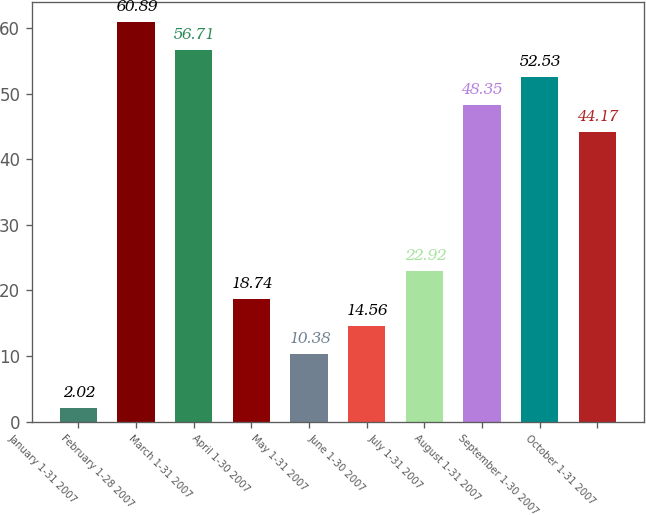Convert chart to OTSL. <chart><loc_0><loc_0><loc_500><loc_500><bar_chart><fcel>January 1-31 2007<fcel>February 1-28 2007<fcel>March 1-31 2007<fcel>April 1-30 2007<fcel>May 1-31 2007<fcel>June 1-30 2007<fcel>July 1-31 2007<fcel>August 1-31 2007<fcel>September 1-30 2007<fcel>October 1-31 2007<nl><fcel>2.02<fcel>60.89<fcel>56.71<fcel>18.74<fcel>10.38<fcel>14.56<fcel>22.92<fcel>48.35<fcel>52.53<fcel>44.17<nl></chart> 